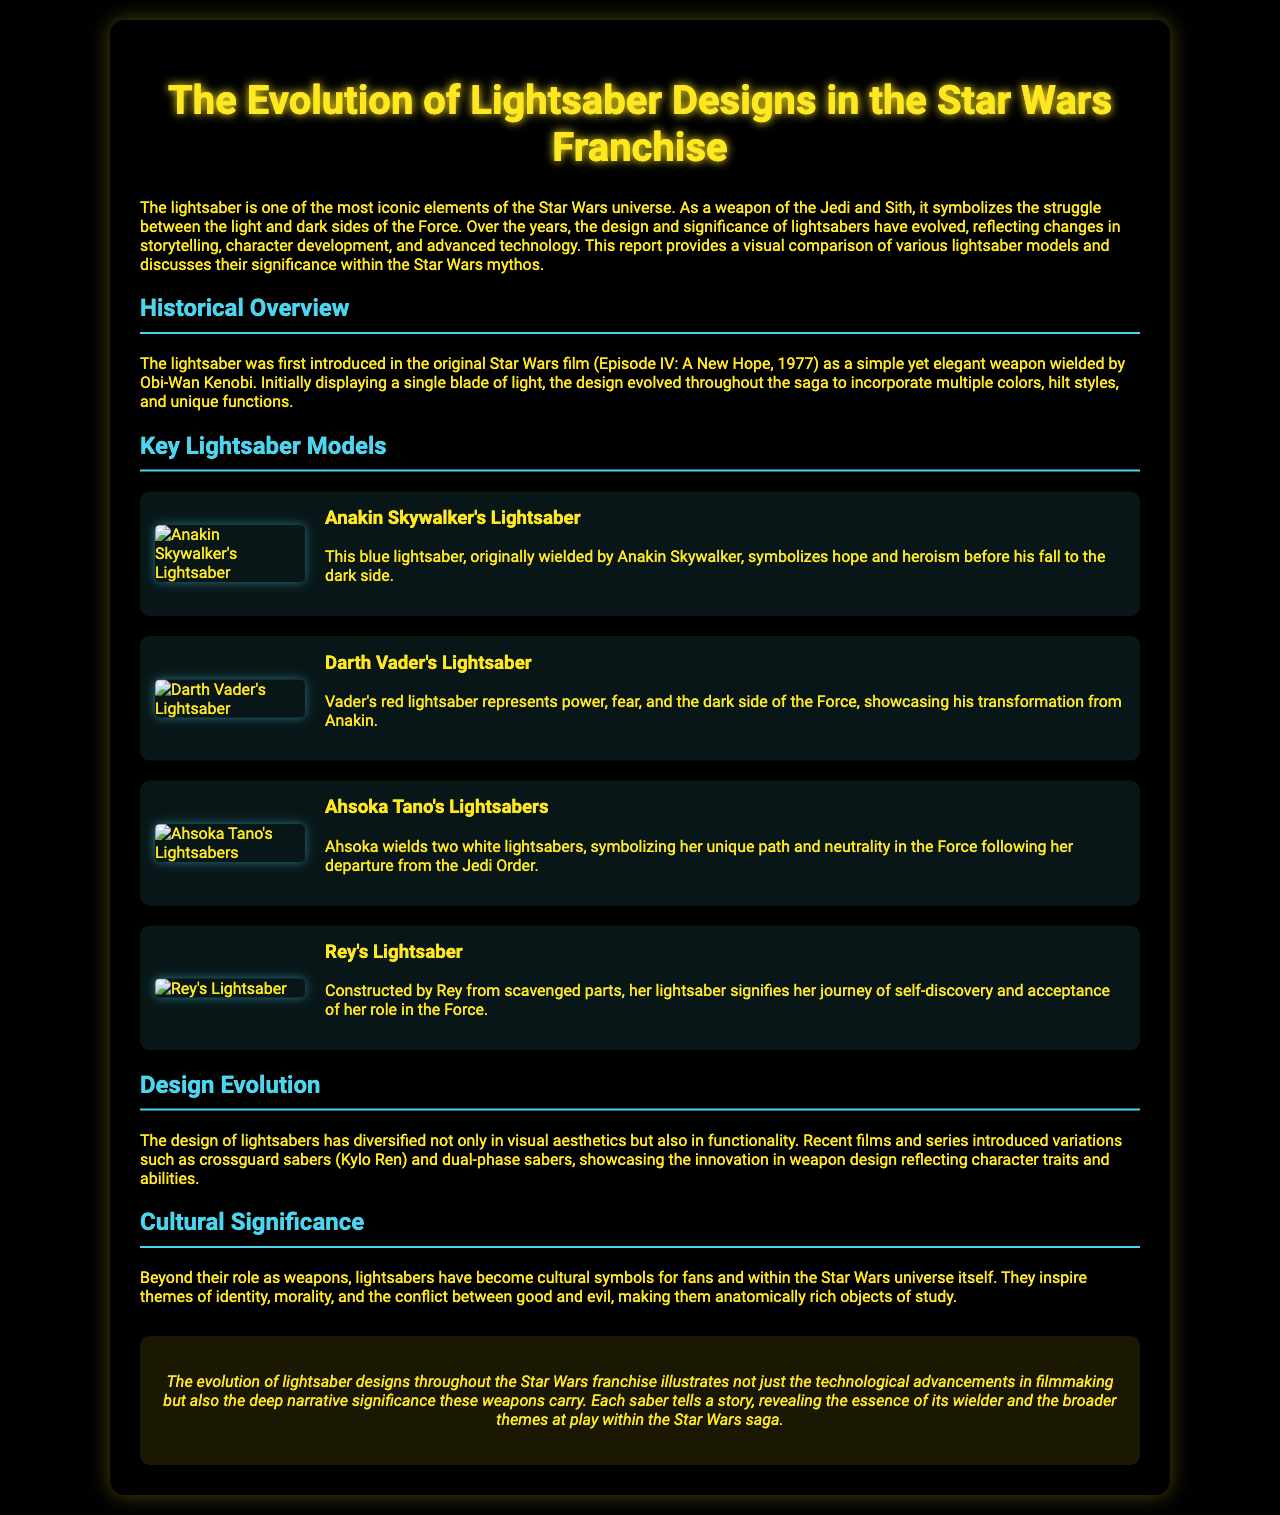what color is Anakin Skywalker's lightsaber? Anakin Skywalker's lightsaber is described as blue in the document.
Answer: blue what does Darth Vader's lightsaber represent? The document states that Darth Vader's lightsaber represents power, fear, and the dark side of the Force.
Answer: power, fear, and the dark side how many lightsabers does Ahsoka Tano wield? Ahsoka Tano is mentioned to wield two lightsabers in the text.
Answer: two what signifies Rey's lightsaber? Rey's lightsaber signifies her journey of self-discovery and acceptance of her role in the Force.
Answer: journey of self-discovery and acceptance which film first introduced the lightsaber? The document specifies that the lightsaber was first introduced in "Episode IV: A New Hope."
Answer: Episode IV: A New Hope what is a key feature of the design evolution of lightsabers? The design evolution of lightsabers includes variations such as crossguard sabers.
Answer: variations such as crossguard sabers how do lightsabers serve in terms of cultural significance? Lightsabers inspire themes of identity, morality, and the conflict between good and evil.
Answer: identity, morality, conflict between good and evil what does the conclusion emphasize about lightsaber designs? The conclusion emphasizes that lightsaber designs illustrate technological advancements and narrative significance.
Answer: technological advancements and narrative significance 